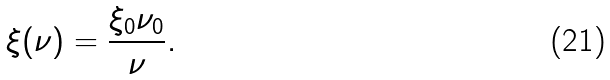Convert formula to latex. <formula><loc_0><loc_0><loc_500><loc_500>\xi ( \nu ) = \frac { \xi _ { 0 } \nu _ { 0 } } { \nu } .</formula> 